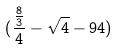<formula> <loc_0><loc_0><loc_500><loc_500>( \frac { \frac { 8 } { 3 } } { 4 } - \sqrt { 4 } - 9 4 )</formula> 